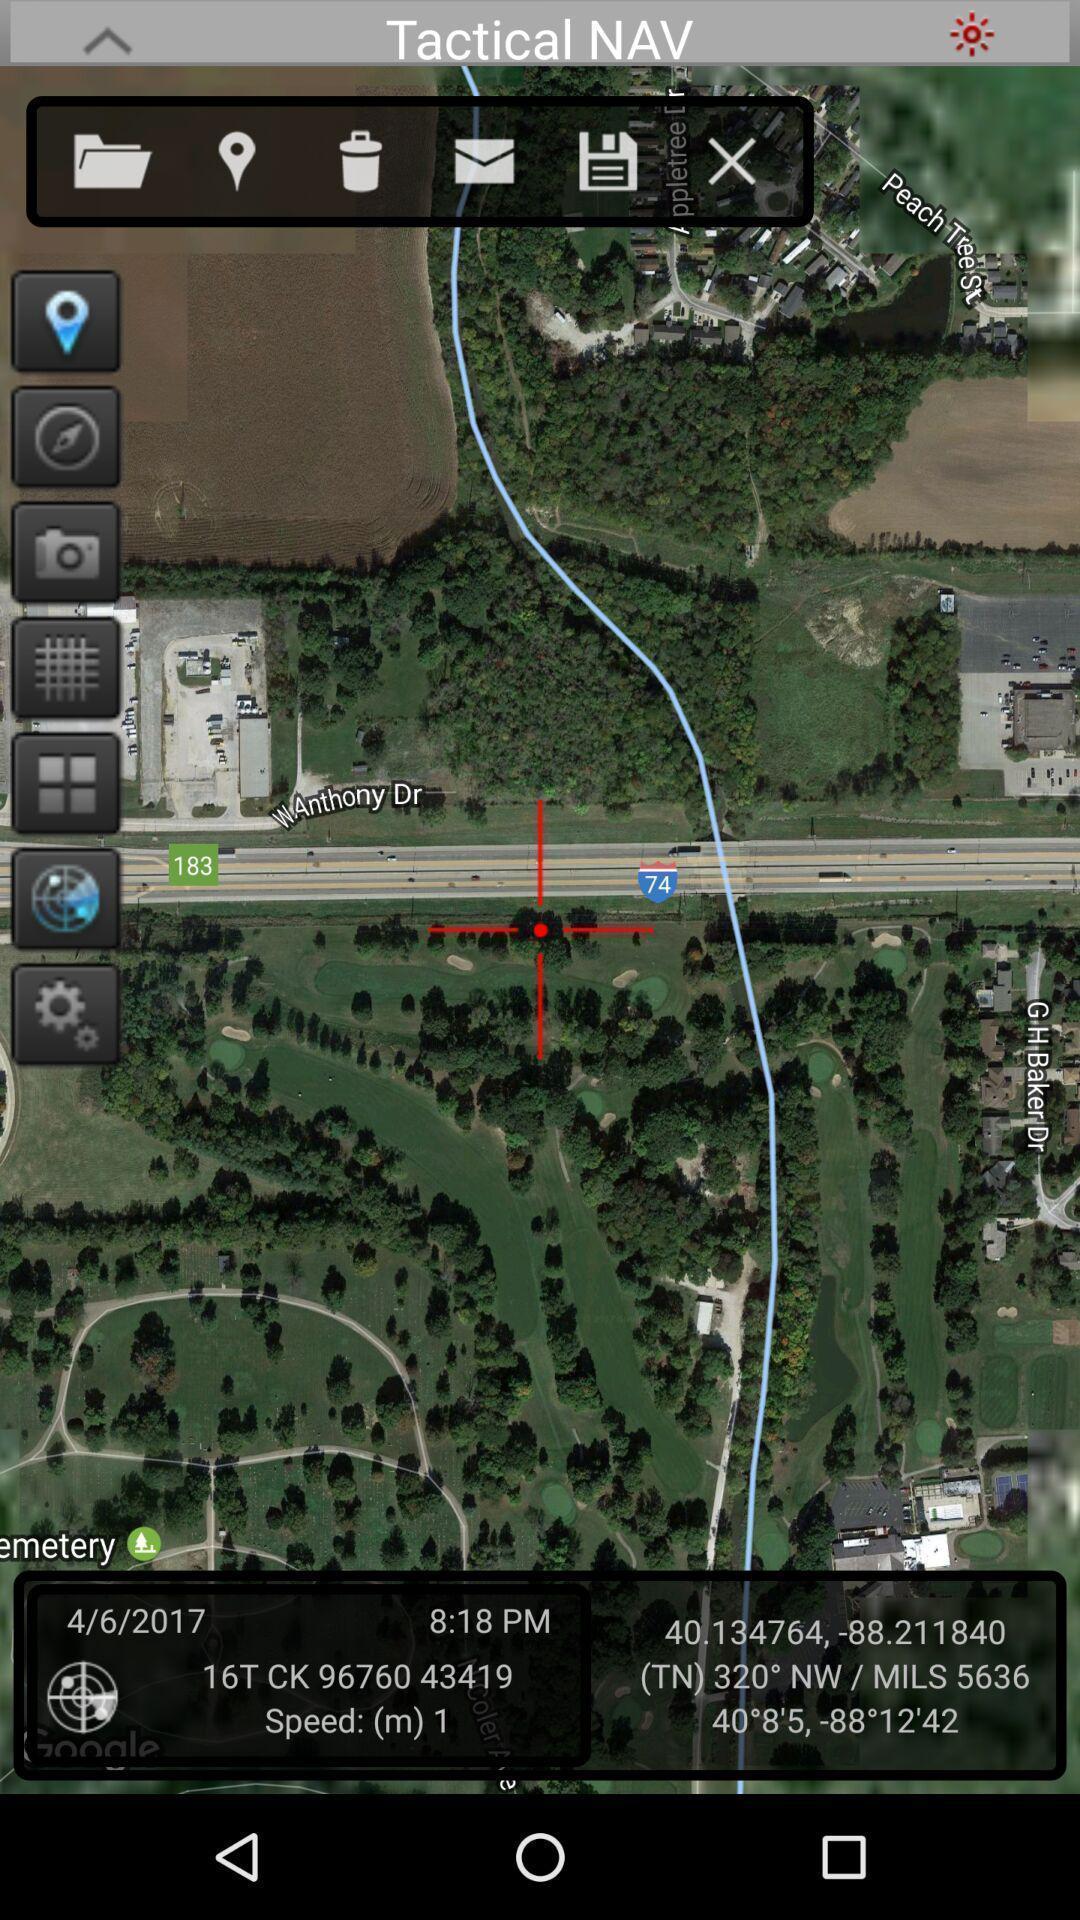What can you discern from this picture? Screen displaying different icons in app. 